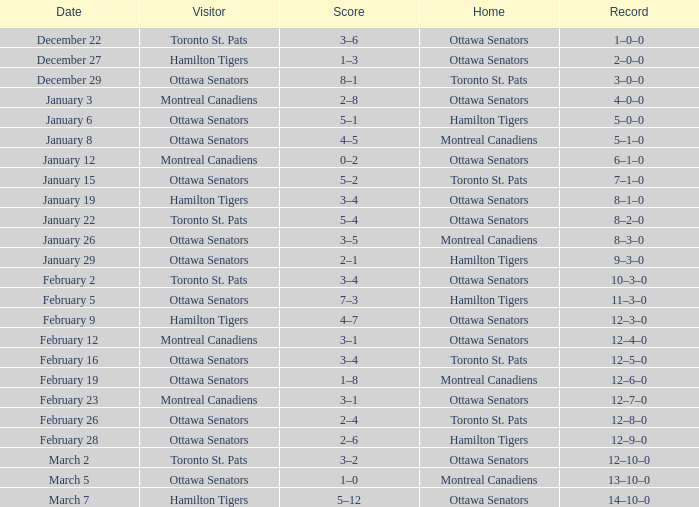What was the result of the game that took place on january 19? 8–1–0. 